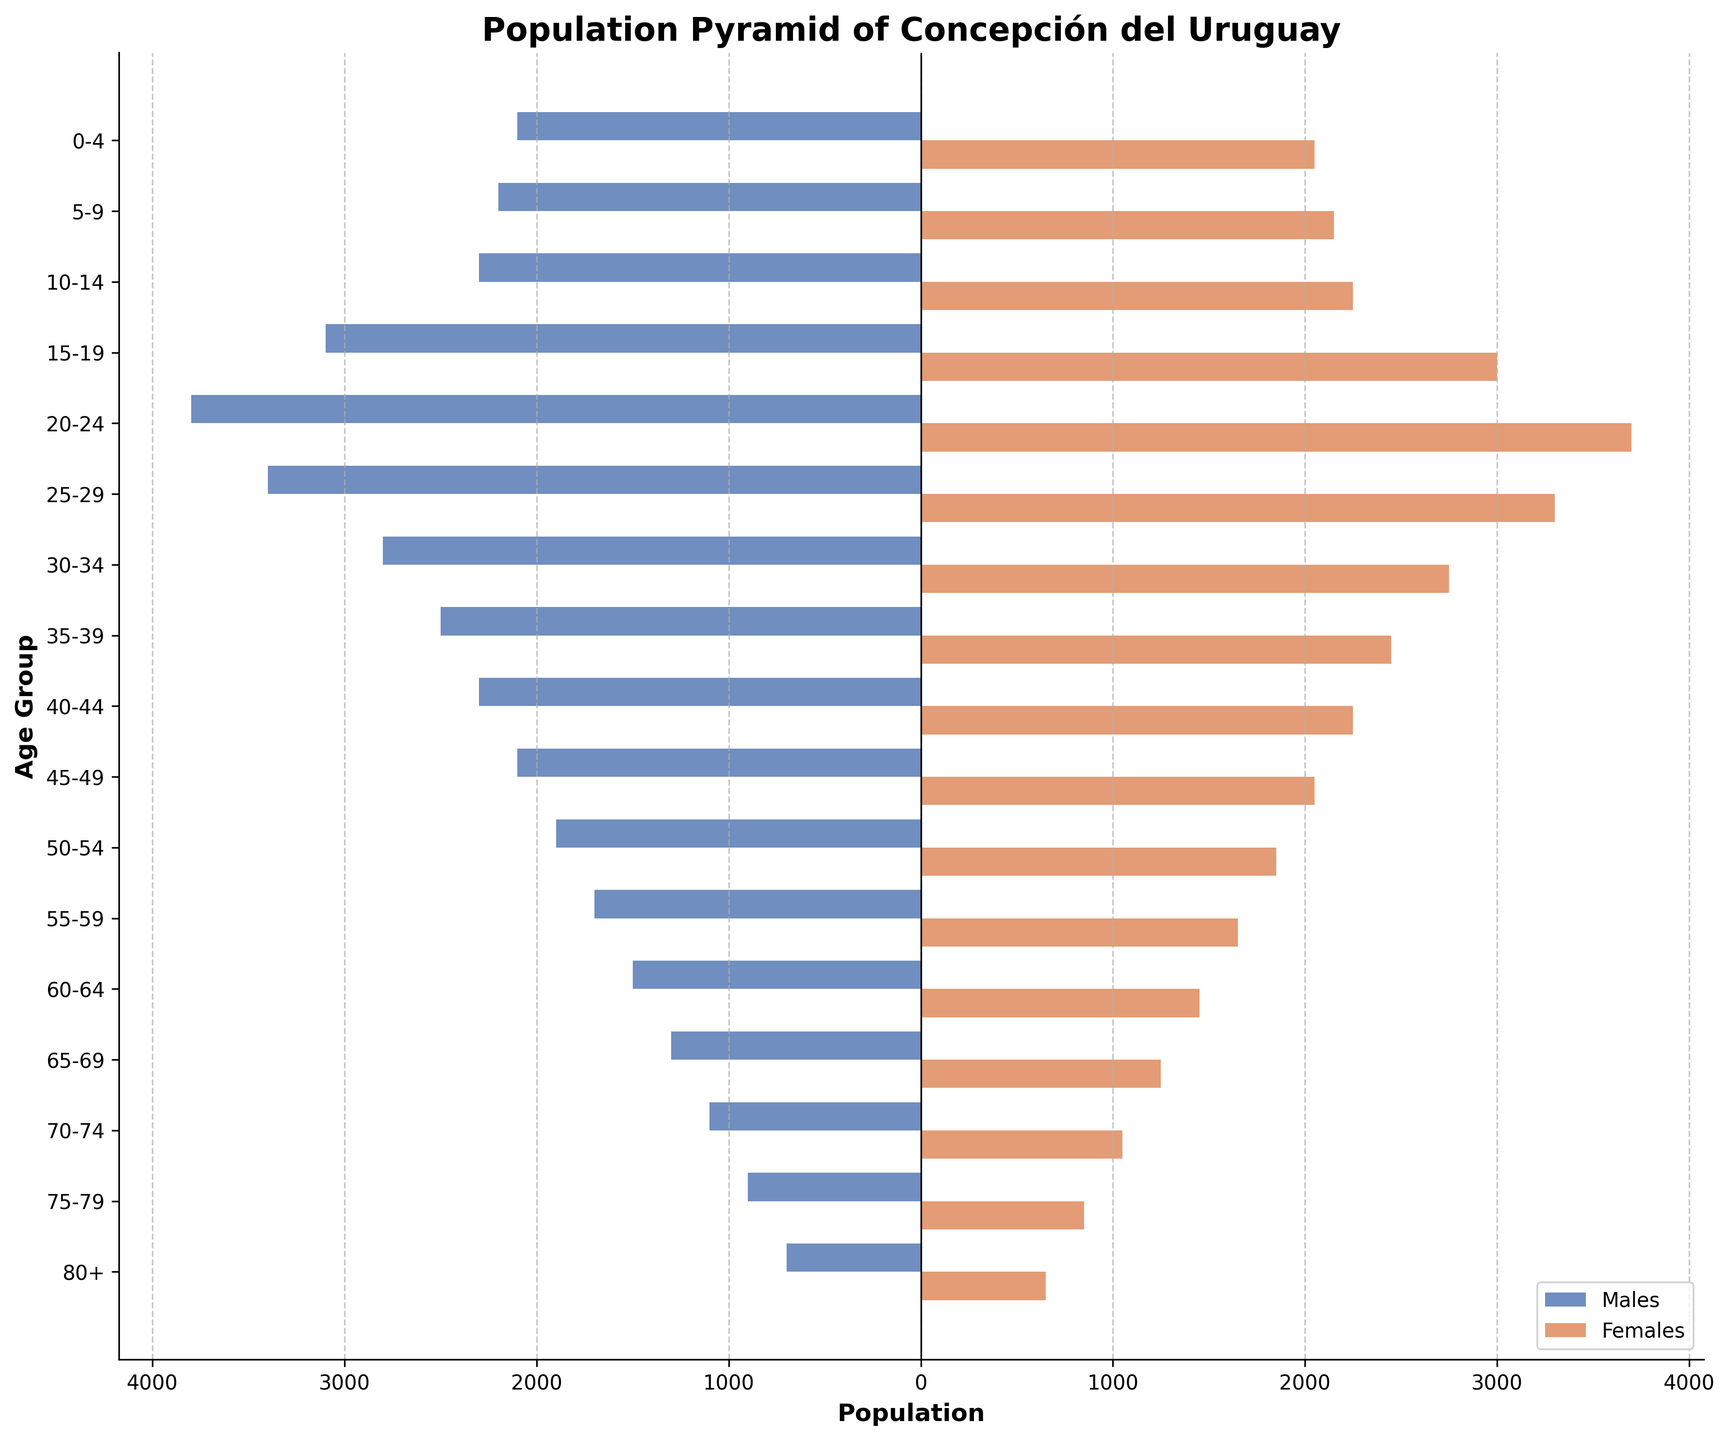What is the title of the figure? The title is usually located at the top of the figure. In this case, it states "Population Pyramid of Concepción del Uruguay".
Answer: Population Pyramid of Concepción del Uruguay What is the age group with the highest population for both males and females? Observe the horizontal bars for each age group and identify the one with the longest bar lengths on both sides. The age group 20-24 has the longest bars for both males and females.
Answer: 20-24 Which gender has more population in the 15-19 age group? Compare the bar lengths for males and females within the 15-19 age group. The male bar extends further to the left than the female bar extends to the right.
Answer: Males What is the total population for the age group 60-64? Sum the populations of both genders in the 60-64 age group by adding the values (1500 for males and 1450 for females). 1500 + 1450 = 2950
Answer: 2950 Which age group has the smallest population? Look for the shortest bars across all age groups. The 80+ age group has the shortest bars for both males and females.
Answer: 80+ How does the population in the 25-29 age group compare between males and females? Observe the bar lengths for the 25-29 age group. Both bars are relatively similar, with males having a slightly longer bar than females (3400 for males, 3300 for females).
Answer: Males have a slightly larger population In which age group is the gender population difference most noticeable? Identify the age group with the largest difference in bar lengths between males and females. In the 20-24 age group, males have 3800 and females have 3700, making it notable but not the largest difference. The 15-19 age group stands out with 3100 males and 3000 females, which is really close as well. However, 80+ category is significantly different since the male population is 700 while female population is 650, which makes it the least obvious in terms of noticeable differences. So answer is, 20-24
Answer: 20-24 Is there a noticeable trend after the age group 35-39? Observe the population bars after the 35-39 age group. Both male and female populations generally decrease with each successive age group.
Answer: The population generally decreases What might account for the significant number of people in the 20-24 age group? The 20-24 age group is traditionally associated with university students. Given the location (Concepción del Uruguay) and the potential influence of local universities, a large population in this group can be attributed to students residing in the city.
Answer: Possible influence of university students How does the female population in the 0-4 age group compare to the female population in the 80+ age group? Compare the bar lengths for females in the 0-4 age group and the 80+ age group. The female population is significantly greater in the 0-4 age group (2050) compared to the 80+ age group (650).
Answer: Much higher in the 0-4 age group 